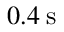Convert formula to latex. <formula><loc_0><loc_0><loc_500><loc_500>0 . 4 \, s</formula> 